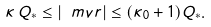<formula> <loc_0><loc_0><loc_500><loc_500>\kappa \, Q _ { * } \leq | \ m v r | \leq ( \kappa _ { 0 } + 1 ) Q _ { * } .</formula> 